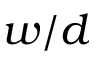<formula> <loc_0><loc_0><loc_500><loc_500>w / d</formula> 